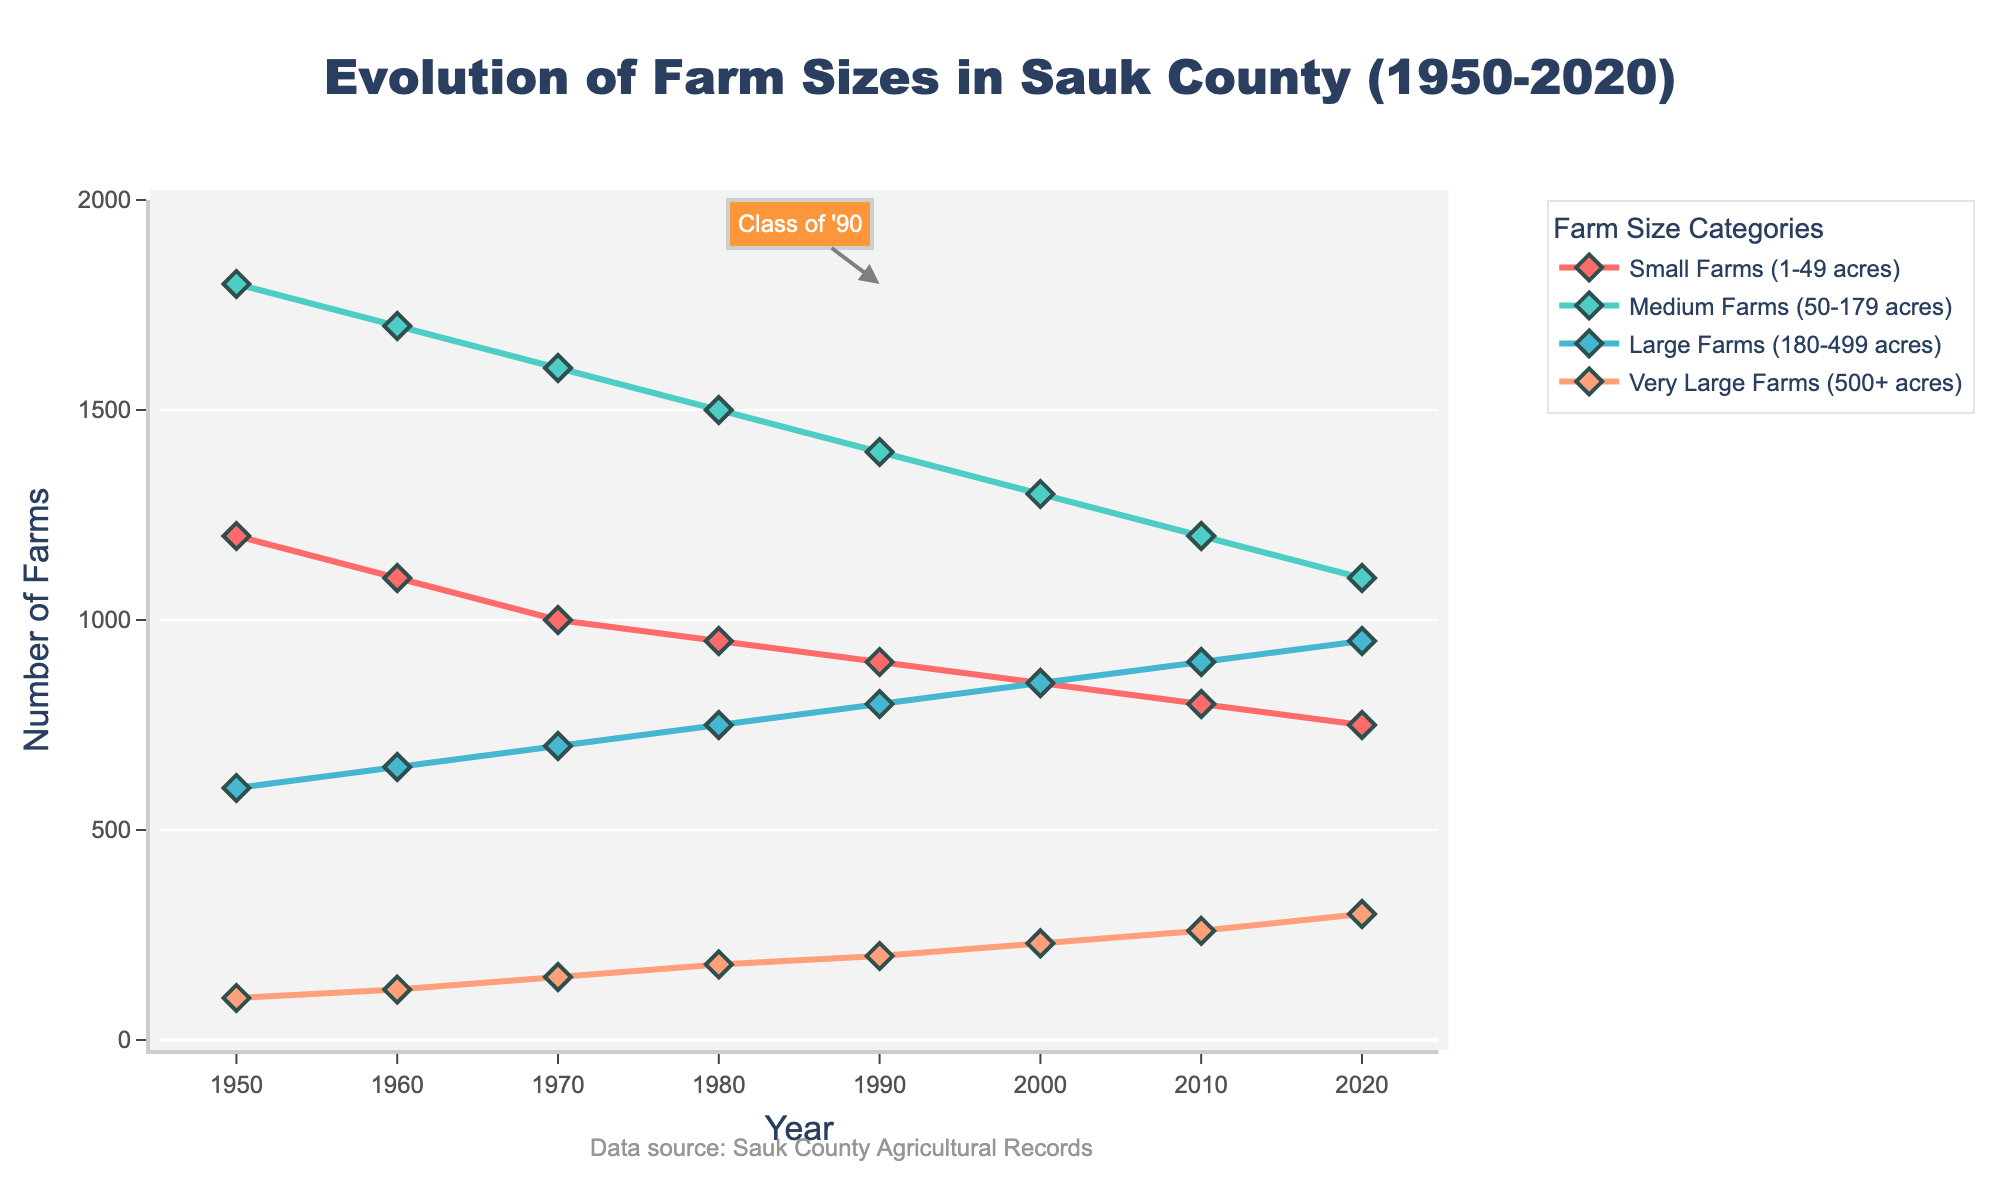What's the trend for the number of small farms (1-49 acres) from 1950 to 2020? The chart shows that the number of small farms (1-49 acres) decreases steadily from 1200 in 1950 to 750 in 2020.
Answer: Decreasing Which farm size category shows the largest increase in the number of farms between 1950 and 2020? Looking at the chart, Very Large Farms (500+ acres) starts at 100 in 1950 and increases to 300 in 2020, showing the largest increase among the categories.
Answer: Very Large Farms (500+ acres) What is the total number of farms in 1980 across all categories? To find the total, we sum the number of farms in each category for 1980: 950 (Small) + 1500 (Medium) + 750 (Large) + 180 (Very Large) = 3380.
Answer: 3380 How did the number of medium farms (50-179 acres) change from 1950 to 2020 compared to large farms (180-499 acres)? From the chart, medium farms decreased from 1800 in 1950 to 1100 in 2020. Large farms increased from 600 in 1950 to 950 in 2020. Thus, medium farms decreased while large farms increased.
Answer: Medium farms decreased, large farms increased What is the percentage change in the number of very large farms (500+ acres) from 1950 to 2020? The number of very large farms increased from 100 in 1950 to 300 in 2020. The percentage change is ((300 - 100) / 100) * 100 = 200%.
Answer: 200% How many farms were there in Sauk County in 2010, and which category had the most farms? Sum the number of farms in 2010 for all categories: 800 (Small) + 1200 (Medium) + 900 (Large) + 260 (Very Large) = 3160. The category with the most farms was Medium Farms with 1200.
Answer: 3160 farms, Medium Farms Which farm size category remained relatively stable from 1950 to 2020? Checking the chart, Large Farms (180-499 acres) have a more stable increase compared to others, rising from 600 in 1950 to 950 in 2020 without substantial fluctuations.
Answer: Large Farms (180-499 acres) How did the combined number of small and medium farms change from 1950 to 2020? Sum the number of small and medium farms for 1950 (1200 + 1800 = 3000) and 2020 (750 + 1100 = 1850). The combined number decreased by 1150.
Answer: Decreased by 1150 In what year did the number of very large farms (500+ acres) first exceed 200? Referring to the chart, the number of very large farms first exceeded 200 in the year 2000 with 230 farms.
Answer: 2000 Which color represents medium farms (50-179 acres) in the chart? The medium farms (50-179 acres) are represented by a green line in the chart.
Answer: Green 